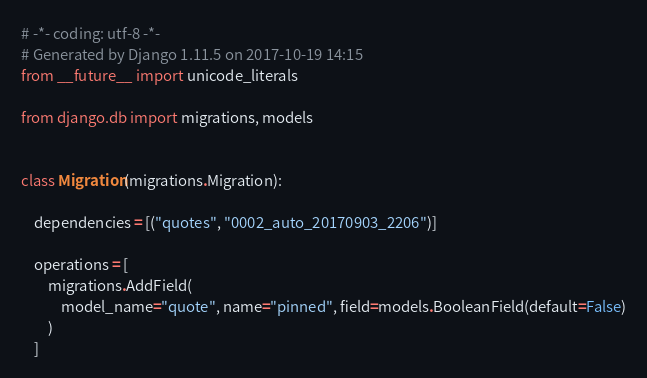<code> <loc_0><loc_0><loc_500><loc_500><_Python_># -*- coding: utf-8 -*-
# Generated by Django 1.11.5 on 2017-10-19 14:15
from __future__ import unicode_literals

from django.db import migrations, models


class Migration(migrations.Migration):

    dependencies = [("quotes", "0002_auto_20170903_2206")]

    operations = [
        migrations.AddField(
            model_name="quote", name="pinned", field=models.BooleanField(default=False)
        )
    ]
</code> 